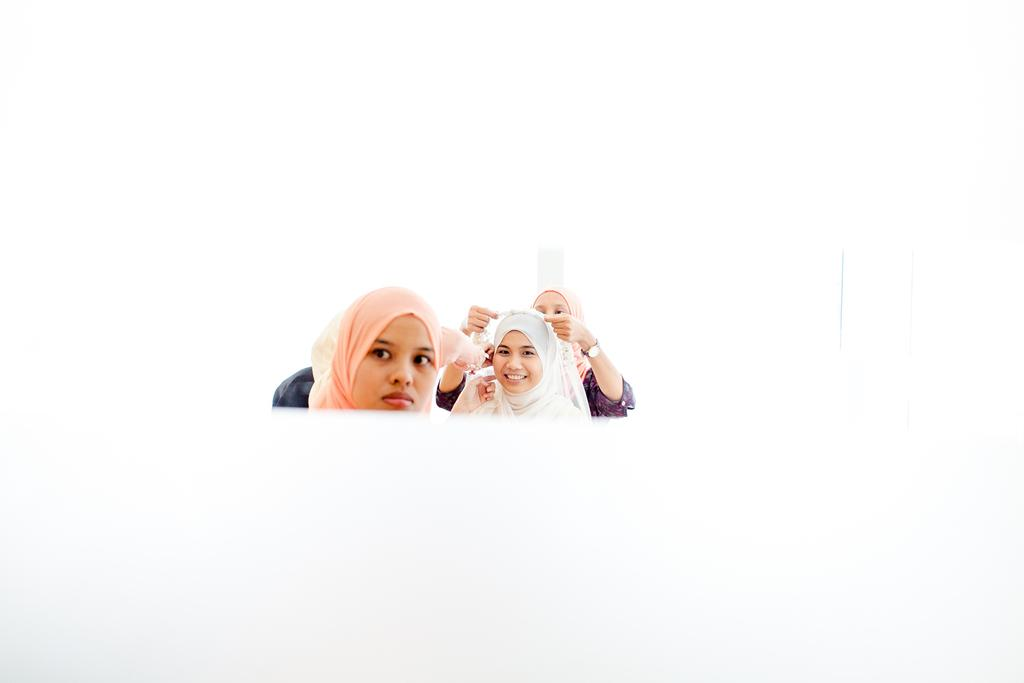How many people are in the image? There are three women in the image. What can be seen in the background of the image? The background of the image is white. What flavor of sheet is being used by the women in the image? There is no sheet present in the image, and therefore no flavor to consider. 